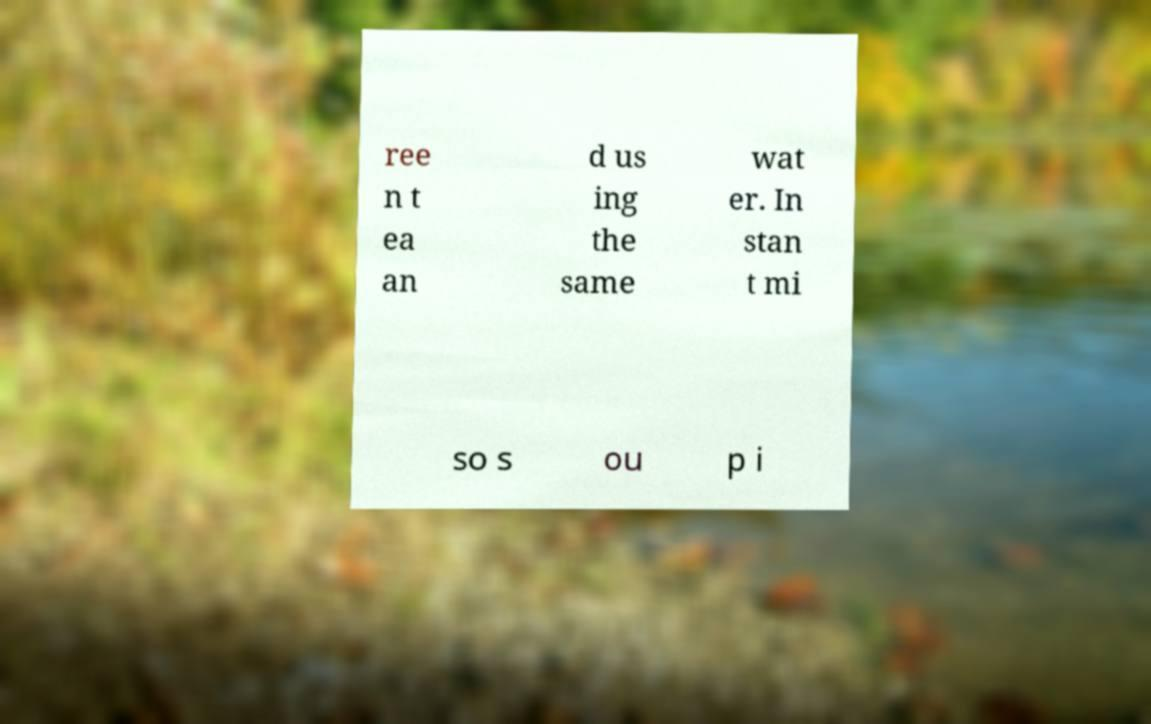Please identify and transcribe the text found in this image. ree n t ea an d us ing the same wat er. In stan t mi so s ou p i 